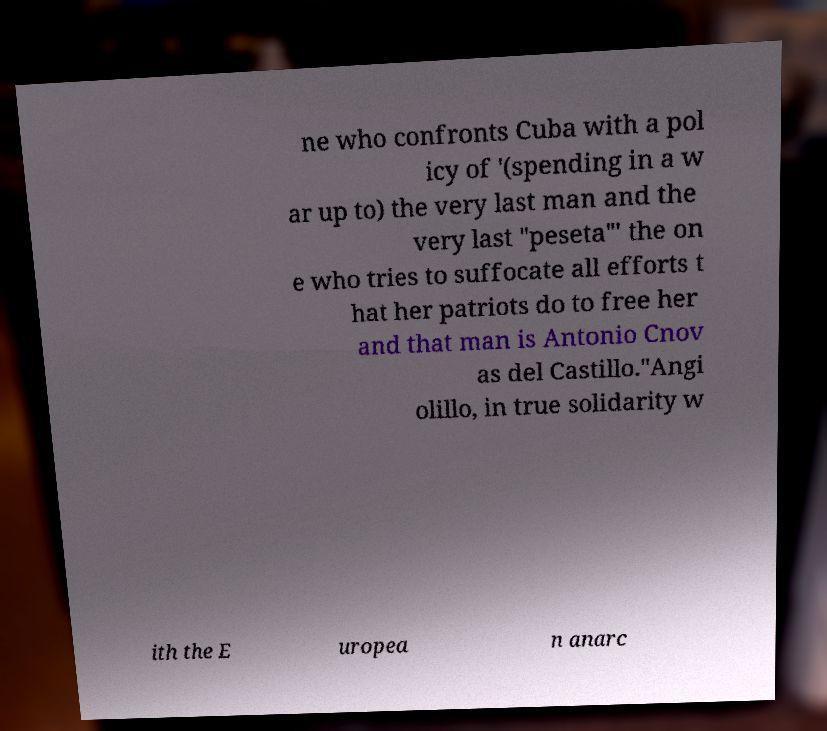I need the written content from this picture converted into text. Can you do that? ne who confronts Cuba with a pol icy of '(spending in a w ar up to) the very last man and the very last "peseta"' the on e who tries to suffocate all efforts t hat her patriots do to free her and that man is Antonio Cnov as del Castillo."Angi olillo, in true solidarity w ith the E uropea n anarc 